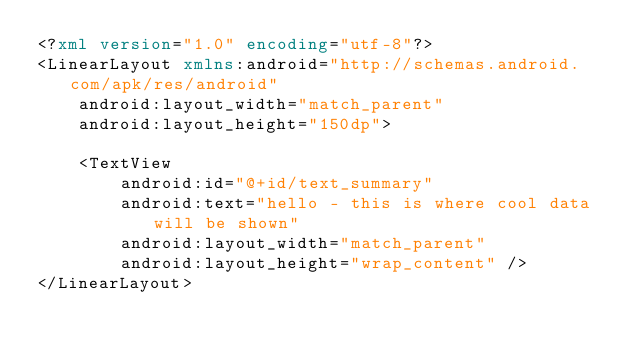Convert code to text. <code><loc_0><loc_0><loc_500><loc_500><_XML_><?xml version="1.0" encoding="utf-8"?>
<LinearLayout xmlns:android="http://schemas.android.com/apk/res/android"
    android:layout_width="match_parent"
    android:layout_height="150dp">

    <TextView
        android:id="@+id/text_summary"
        android:text="hello - this is where cool data will be shown"
        android:layout_width="match_parent"
        android:layout_height="wrap_content" />
</LinearLayout>
</code> 